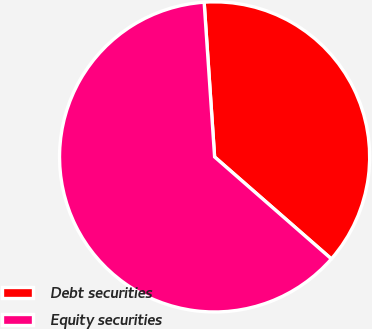Convert chart to OTSL. <chart><loc_0><loc_0><loc_500><loc_500><pie_chart><fcel>Debt securities<fcel>Equity securities<nl><fcel>37.5%<fcel>62.5%<nl></chart> 